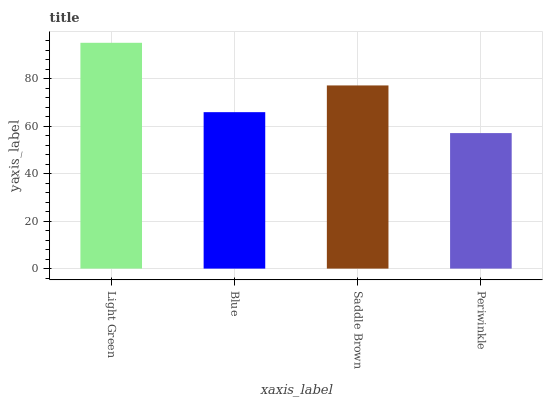Is Periwinkle the minimum?
Answer yes or no. Yes. Is Light Green the maximum?
Answer yes or no. Yes. Is Blue the minimum?
Answer yes or no. No. Is Blue the maximum?
Answer yes or no. No. Is Light Green greater than Blue?
Answer yes or no. Yes. Is Blue less than Light Green?
Answer yes or no. Yes. Is Blue greater than Light Green?
Answer yes or no. No. Is Light Green less than Blue?
Answer yes or no. No. Is Saddle Brown the high median?
Answer yes or no. Yes. Is Blue the low median?
Answer yes or no. Yes. Is Blue the high median?
Answer yes or no. No. Is Light Green the low median?
Answer yes or no. No. 